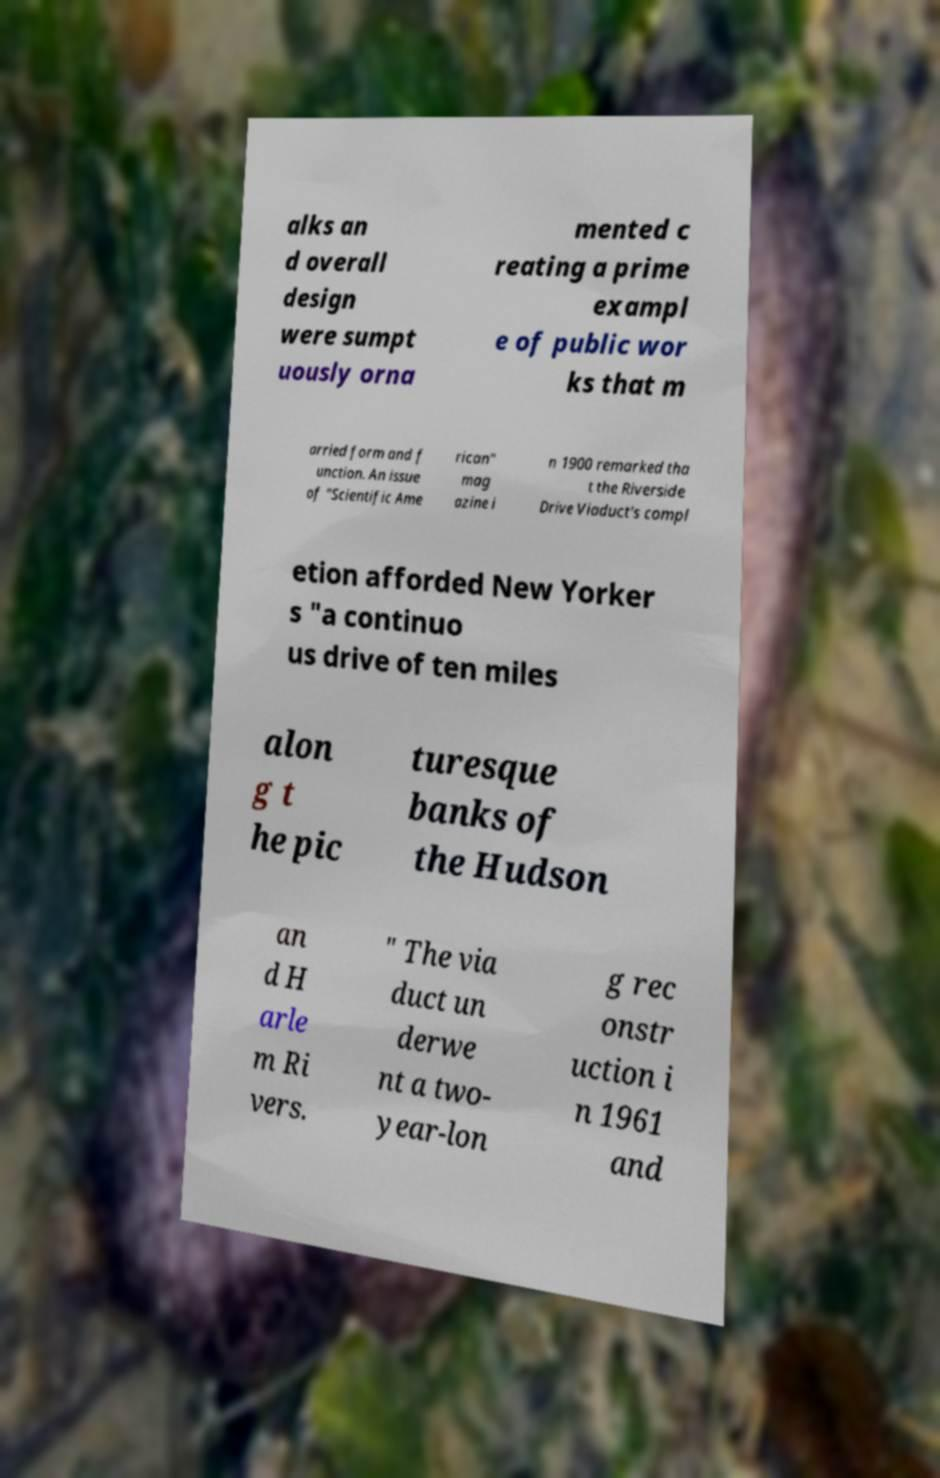Can you accurately transcribe the text from the provided image for me? alks an d overall design were sumpt uously orna mented c reating a prime exampl e of public wor ks that m arried form and f unction. An issue of "Scientific Ame rican" mag azine i n 1900 remarked tha t the Riverside Drive Viaduct's compl etion afforded New Yorker s "a continuo us drive of ten miles alon g t he pic turesque banks of the Hudson an d H arle m Ri vers. " The via duct un derwe nt a two- year-lon g rec onstr uction i n 1961 and 